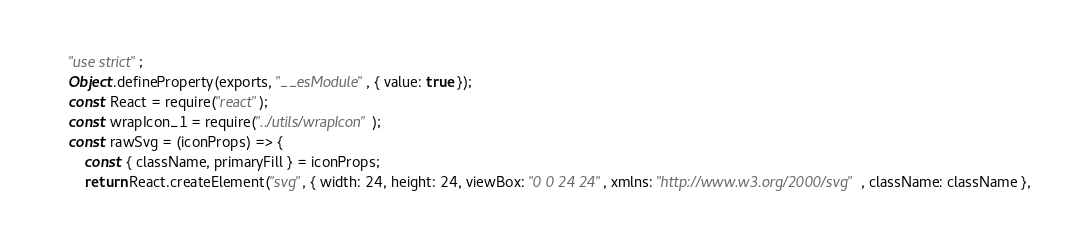<code> <loc_0><loc_0><loc_500><loc_500><_JavaScript_>"use strict";
Object.defineProperty(exports, "__esModule", { value: true });
const React = require("react");
const wrapIcon_1 = require("../utils/wrapIcon");
const rawSvg = (iconProps) => {
    const { className, primaryFill } = iconProps;
    return React.createElement("svg", { width: 24, height: 24, viewBox: "0 0 24 24", xmlns: "http://www.w3.org/2000/svg", className: className },</code> 